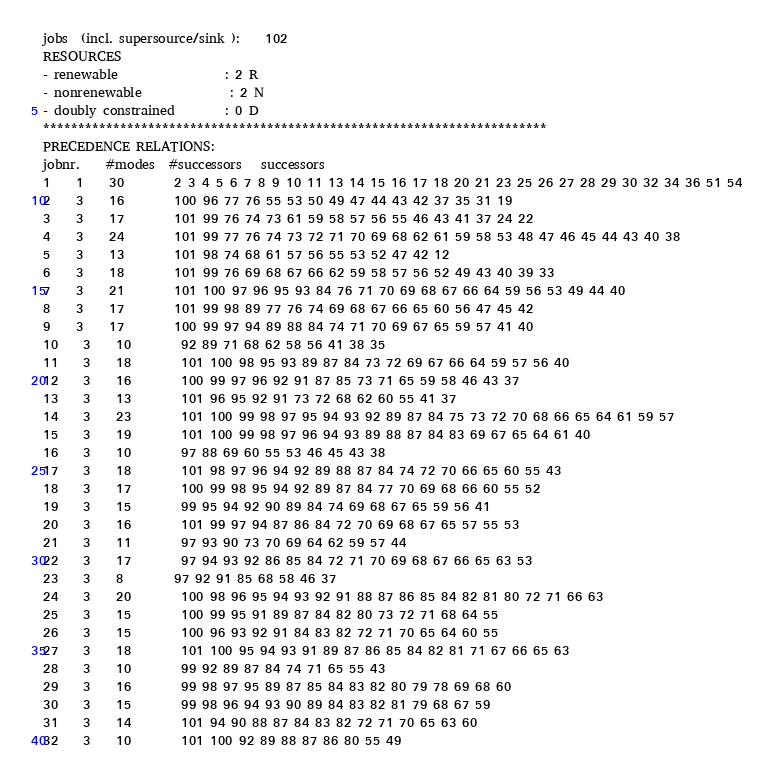Convert code to text. <code><loc_0><loc_0><loc_500><loc_500><_ObjectiveC_>jobs  (incl. supersource/sink ):	102
RESOURCES
- renewable                 : 2 R
- nonrenewable              : 2 N
- doubly constrained        : 0 D
************************************************************************
PRECEDENCE RELATIONS:
jobnr.    #modes  #successors   successors
1	1	30		2 3 4 5 6 7 8 9 10 11 13 14 15 16 17 18 20 21 23 25 26 27 28 29 30 32 34 36 51 54 
2	3	16		100 96 77 76 55 53 50 49 47 44 43 42 37 35 31 19 
3	3	17		101 99 76 74 73 61 59 58 57 56 55 46 43 41 37 24 22 
4	3	24		101 99 77 76 74 73 72 71 70 69 68 62 61 59 58 53 48 47 46 45 44 43 40 38 
5	3	13		101 98 74 68 61 57 56 55 53 52 47 42 12 
6	3	18		101 99 76 69 68 67 66 62 59 58 57 56 52 49 43 40 39 33 
7	3	21		101 100 97 96 95 93 84 76 71 70 69 68 67 66 64 59 56 53 49 44 40 
8	3	17		101 99 98 89 77 76 74 69 68 67 66 65 60 56 47 45 42 
9	3	17		100 99 97 94 89 88 84 74 71 70 69 67 65 59 57 41 40 
10	3	10		92 89 71 68 62 58 56 41 38 35 
11	3	18		101 100 98 95 93 89 87 84 73 72 69 67 66 64 59 57 56 40 
12	3	16		100 99 97 96 92 91 87 85 73 71 65 59 58 46 43 37 
13	3	13		101 96 95 92 91 73 72 68 62 60 55 41 37 
14	3	23		101 100 99 98 97 95 94 93 92 89 87 84 75 73 72 70 68 66 65 64 61 59 57 
15	3	19		101 100 99 98 97 96 94 93 89 88 87 84 83 69 67 65 64 61 40 
16	3	10		97 88 69 60 55 53 46 45 43 38 
17	3	18		101 98 97 96 94 92 89 88 87 84 74 72 70 66 65 60 55 43 
18	3	17		100 99 98 95 94 92 89 87 84 77 70 69 68 66 60 55 52 
19	3	15		99 95 94 92 90 89 84 74 69 68 67 65 59 56 41 
20	3	16		101 99 97 94 87 86 84 72 70 69 68 67 65 57 55 53 
21	3	11		97 93 90 73 70 69 64 62 59 57 44 
22	3	17		97 94 93 92 86 85 84 72 71 70 69 68 67 66 65 63 53 
23	3	8		97 92 91 85 68 58 46 37 
24	3	20		100 98 96 95 94 93 92 91 88 87 86 85 84 82 81 80 72 71 66 63 
25	3	15		100 99 95 91 89 87 84 82 80 73 72 71 68 64 55 
26	3	15		100 96 93 92 91 84 83 82 72 71 70 65 64 60 55 
27	3	18		101 100 95 94 93 91 89 87 86 85 84 82 81 71 67 66 65 63 
28	3	10		99 92 89 87 84 74 71 65 55 43 
29	3	16		99 98 97 95 89 87 85 84 83 82 80 79 78 69 68 60 
30	3	15		99 98 96 94 93 90 89 84 83 82 81 79 68 67 59 
31	3	14		101 94 90 88 87 84 83 82 72 71 70 65 63 60 
32	3	10		101 100 92 89 88 87 86 80 55 49 </code> 